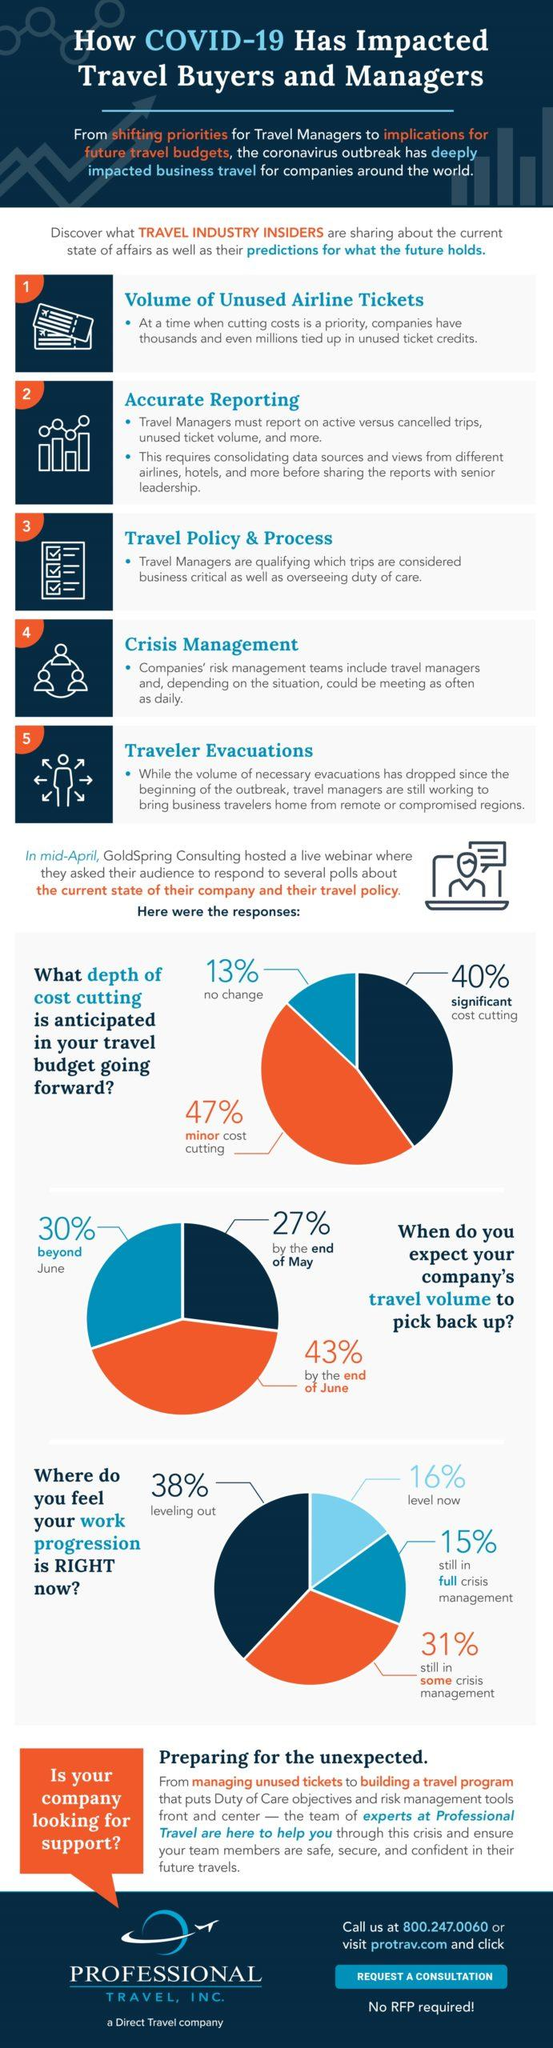Give some essential details in this illustration. The question asks about the highest share of cost-cutting that is significant or minor. The speaker is asking about the different levels of cost-cutting and the proportion of costs that are being reduced. The product with the highest share will have the highest share-beyond June, by the end of June. The company with the highest share in crisis management is leveling out and no longer in a crisis. 